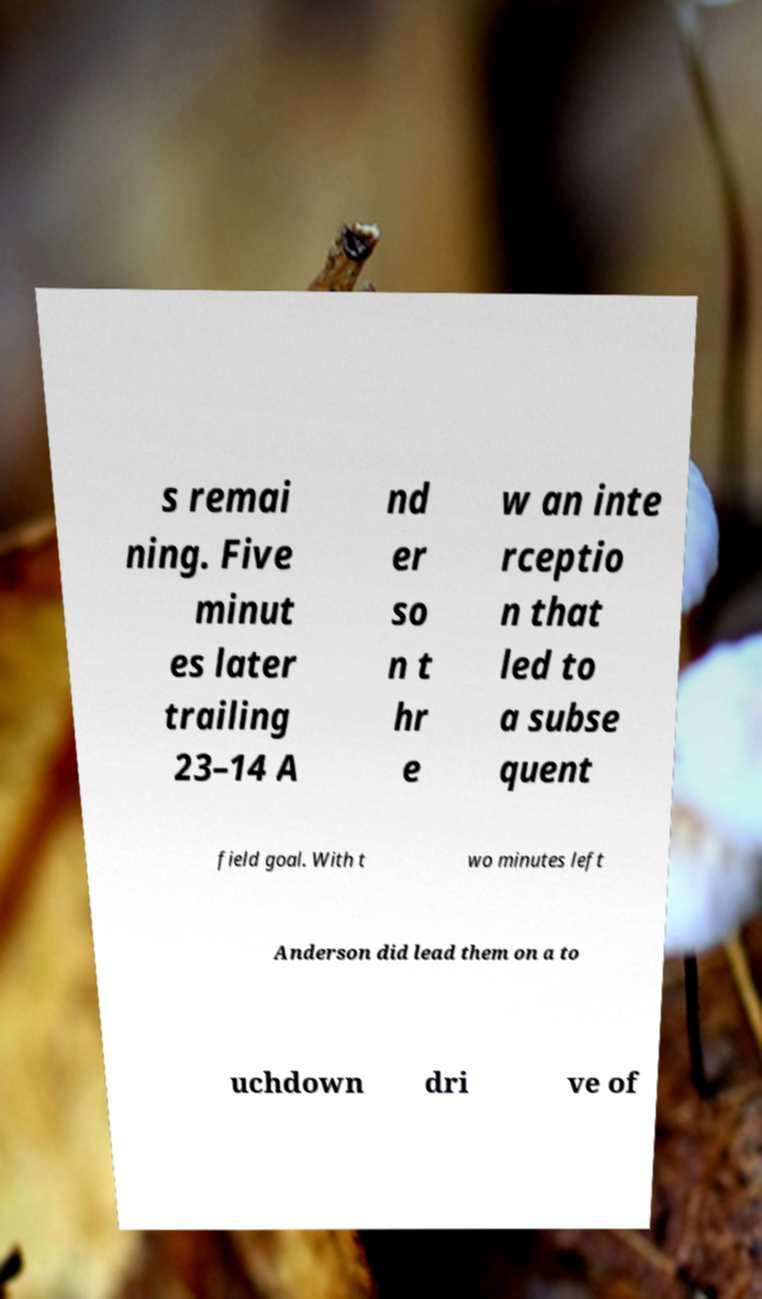What messages or text are displayed in this image? I need them in a readable, typed format. s remai ning. Five minut es later trailing 23–14 A nd er so n t hr e w an inte rceptio n that led to a subse quent field goal. With t wo minutes left Anderson did lead them on a to uchdown dri ve of 